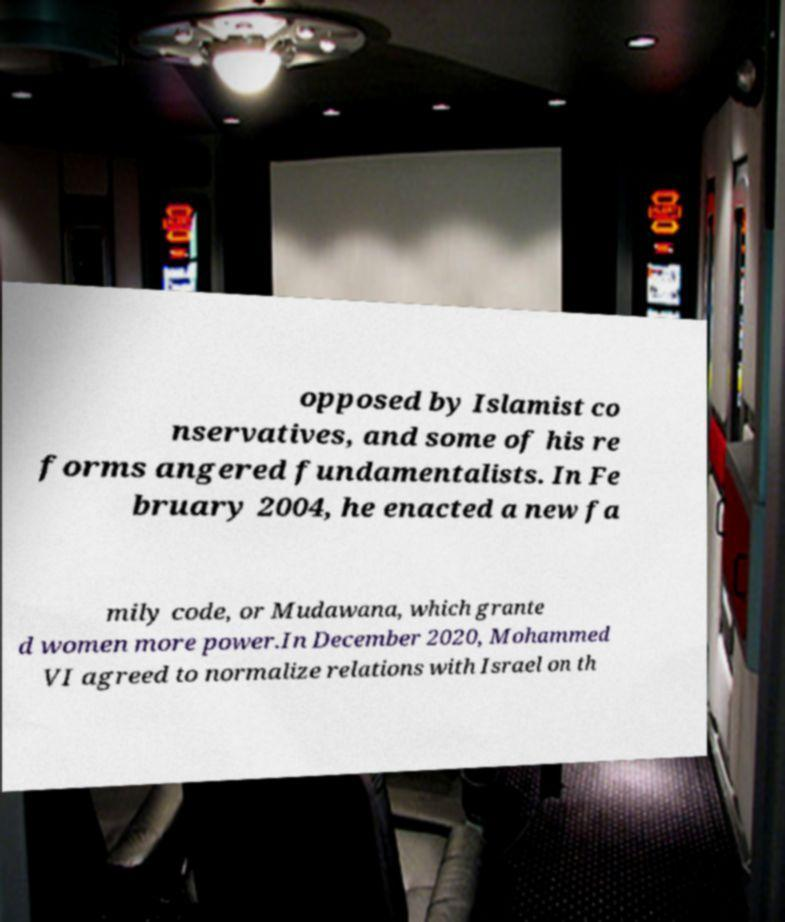Could you extract and type out the text from this image? opposed by Islamist co nservatives, and some of his re forms angered fundamentalists. In Fe bruary 2004, he enacted a new fa mily code, or Mudawana, which grante d women more power.In December 2020, Mohammed VI agreed to normalize relations with Israel on th 